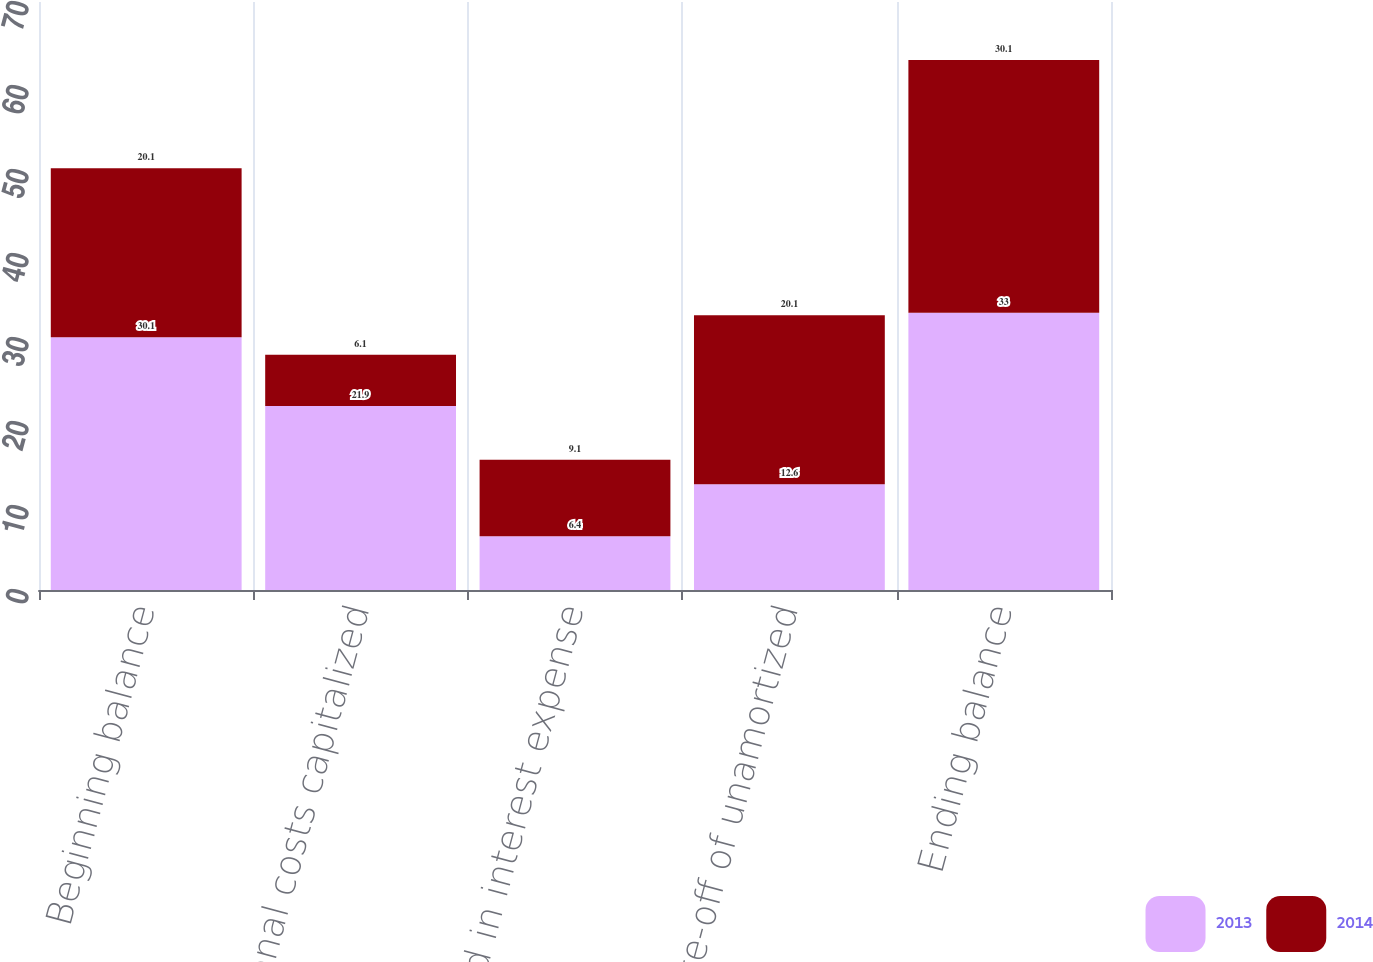Convert chart. <chart><loc_0><loc_0><loc_500><loc_500><stacked_bar_chart><ecel><fcel>Beginning balance<fcel>Additional costs capitalized<fcel>Recognized in interest expense<fcel>Write-off of unamortized<fcel>Ending balance<nl><fcel>2013<fcel>30.1<fcel>21.9<fcel>6.4<fcel>12.6<fcel>33<nl><fcel>2014<fcel>20.1<fcel>6.1<fcel>9.1<fcel>20.1<fcel>30.1<nl></chart> 